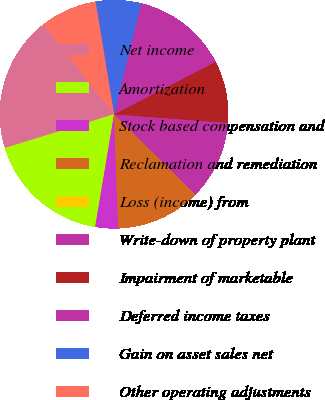Convert chart. <chart><loc_0><loc_0><loc_500><loc_500><pie_chart><fcel>Net income<fcel>Amortization<fcel>Stock based compensation and<fcel>Reclamation and remediation<fcel>Loss (income) from<fcel>Write-down of property plant<fcel>Impairment of marketable<fcel>Deferred income taxes<fcel>Gain on asset sales net<fcel>Other operating adjustments<nl><fcel>19.18%<fcel>17.58%<fcel>3.22%<fcel>12.0%<fcel>0.02%<fcel>11.2%<fcel>8.8%<fcel>13.59%<fcel>6.41%<fcel>8.0%<nl></chart> 